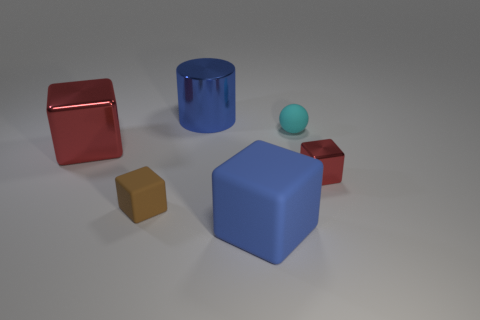Subtract all red cubes. How many were subtracted if there are1red cubes left? 1 Subtract all purple cubes. Subtract all yellow spheres. How many cubes are left? 4 Add 4 large brown matte cylinders. How many objects exist? 10 Subtract all spheres. How many objects are left? 5 Subtract all brown things. Subtract all big red metal cubes. How many objects are left? 4 Add 1 red cubes. How many red cubes are left? 3 Add 3 small metallic blocks. How many small metallic blocks exist? 4 Subtract 1 brown cubes. How many objects are left? 5 